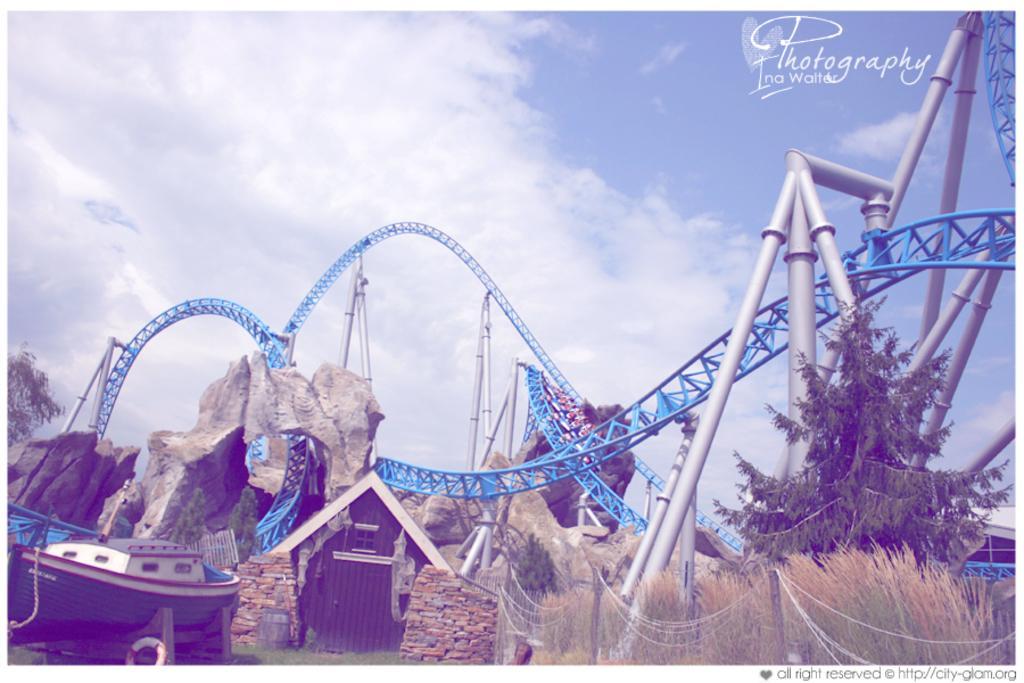Could you give a brief overview of what you see in this image? In this image I can see an amusement park ride. I can see colour of this is blue and colour of these poles are silver. I can also see few trees, bushes, a shack and here I can see a boat. In the background I can see clouds and the sky. 